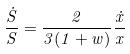Convert formula to latex. <formula><loc_0><loc_0><loc_500><loc_500>\frac { \dot { S } } { S } = \frac { 2 } { 3 ( 1 + w ) } \frac { \dot { x } } { x }</formula> 